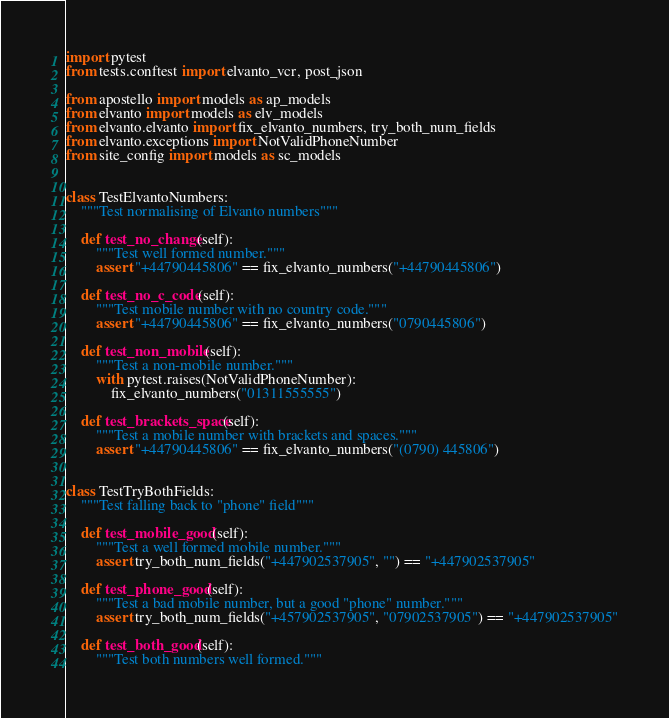<code> <loc_0><loc_0><loc_500><loc_500><_Python_>import pytest
from tests.conftest import elvanto_vcr, post_json

from apostello import models as ap_models
from elvanto import models as elv_models
from elvanto.elvanto import fix_elvanto_numbers, try_both_num_fields
from elvanto.exceptions import NotValidPhoneNumber
from site_config import models as sc_models


class TestElvantoNumbers:
    """Test normalising of Elvanto numbers"""

    def test_no_change(self):
        """Test well formed number."""
        assert "+44790445806" == fix_elvanto_numbers("+44790445806")

    def test_no_c_code(self):
        """Test mobile number with no country code."""
        assert "+44790445806" == fix_elvanto_numbers("0790445806")

    def test_non_mobile(self):
        """Test a non-mobile number."""
        with pytest.raises(NotValidPhoneNumber):
            fix_elvanto_numbers("01311555555")

    def test_brackets_space(self):
        """Test a mobile number with brackets and spaces."""
        assert "+44790445806" == fix_elvanto_numbers("(0790) 445806")


class TestTryBothFields:
    """Test falling back to "phone" field"""

    def test_mobile_good(self):
        """Test a well formed mobile number."""
        assert try_both_num_fields("+447902537905", "") == "+447902537905"

    def test_phone_good(self):
        """Test a bad mobile number, but a good "phone" number."""
        assert try_both_num_fields("+457902537905", "07902537905") == "+447902537905"

    def test_both_good(self):
        """Test both numbers well formed."""</code> 